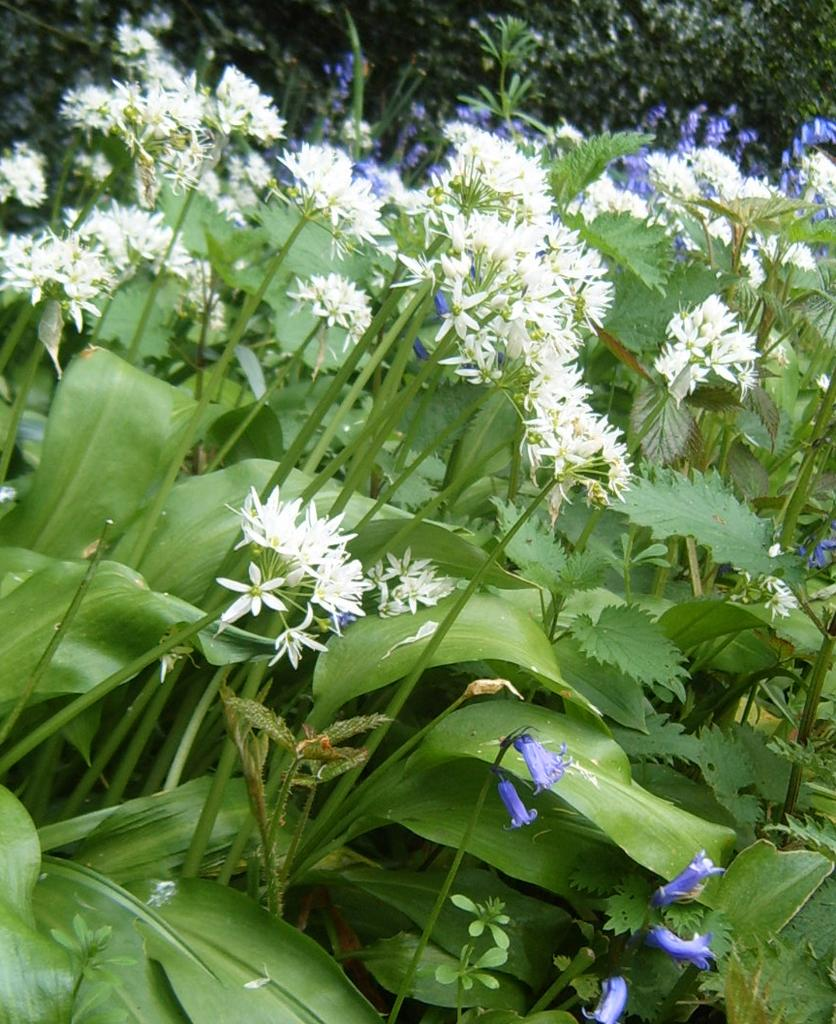What types of vegetation can be seen in the image? There are many plants in the image. Are there any specific features of the plants? Yes, there are white flowers on the plants. What can be seen in the background of the image? There are trees visible in the background of the image. What type of cloth is draped over the plants in the image? There is no cloth present in the image; it features plants with white flowers and trees in the background. Can you read any letters on the plants in the image? There are no letters present on the plants in the image; it only features plants with white flowers and trees in the background. 